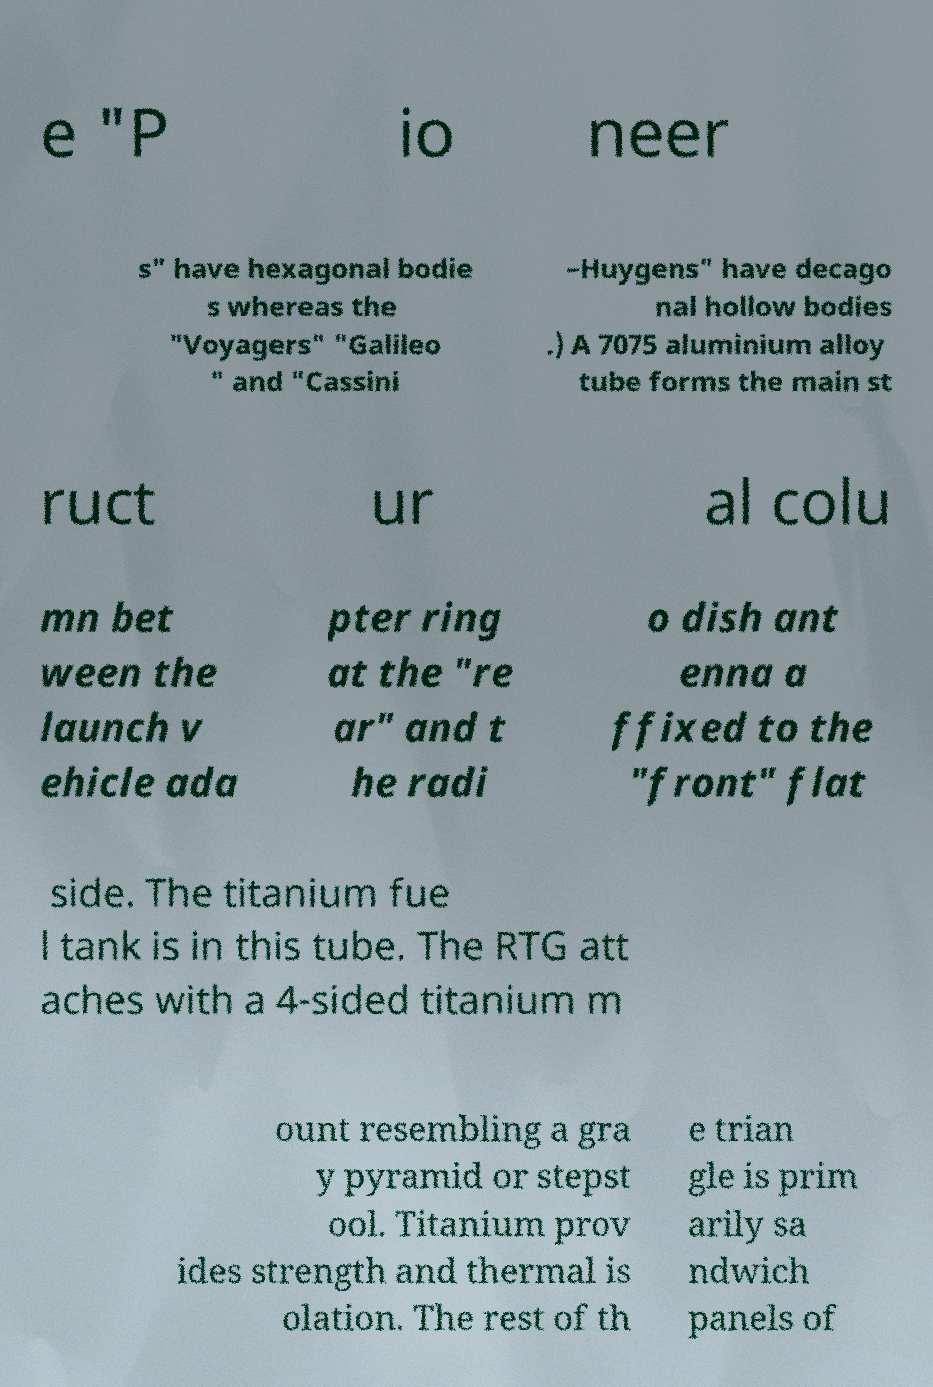Could you extract and type out the text from this image? e "P io neer s" have hexagonal bodie s whereas the "Voyagers" "Galileo " and "Cassini –Huygens" have decago nal hollow bodies .) A 7075 aluminium alloy tube forms the main st ruct ur al colu mn bet ween the launch v ehicle ada pter ring at the "re ar" and t he radi o dish ant enna a ffixed to the "front" flat side. The titanium fue l tank is in this tube. The RTG att aches with a 4-sided titanium m ount resembling a gra y pyramid or stepst ool. Titanium prov ides strength and thermal is olation. The rest of th e trian gle is prim arily sa ndwich panels of 